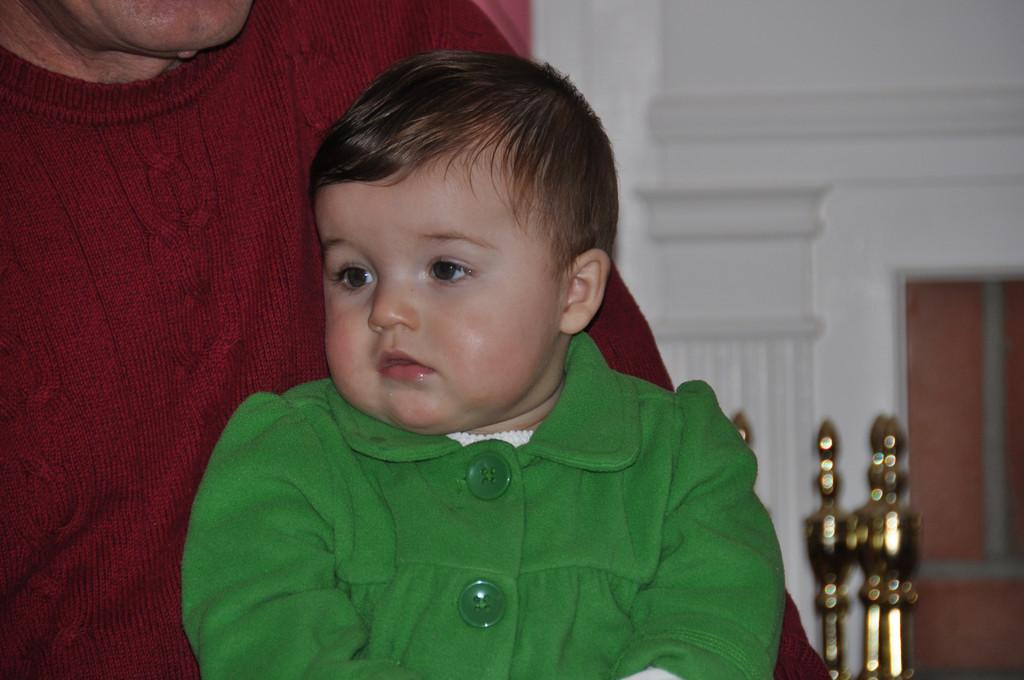What is the person in the image doing? The person is holding a baby in the image. What can be seen in the background of the image? There is a wall visible in the background of the image. What type of spark can be seen coming from the baby's head in the image? There is no spark present in the image; there is only a person holding a baby and a wall visible in the background. 